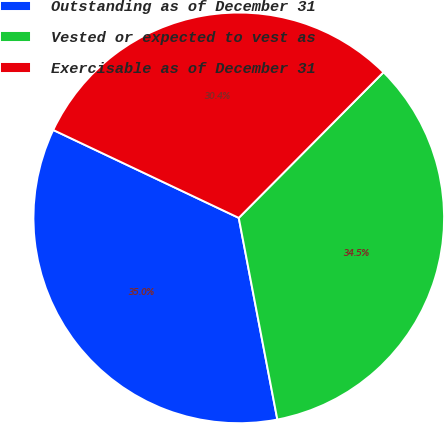Convert chart to OTSL. <chart><loc_0><loc_0><loc_500><loc_500><pie_chart><fcel>Outstanding as of December 31<fcel>Vested or expected to vest as<fcel>Exercisable as of December 31<nl><fcel>35.05%<fcel>34.54%<fcel>30.41%<nl></chart> 